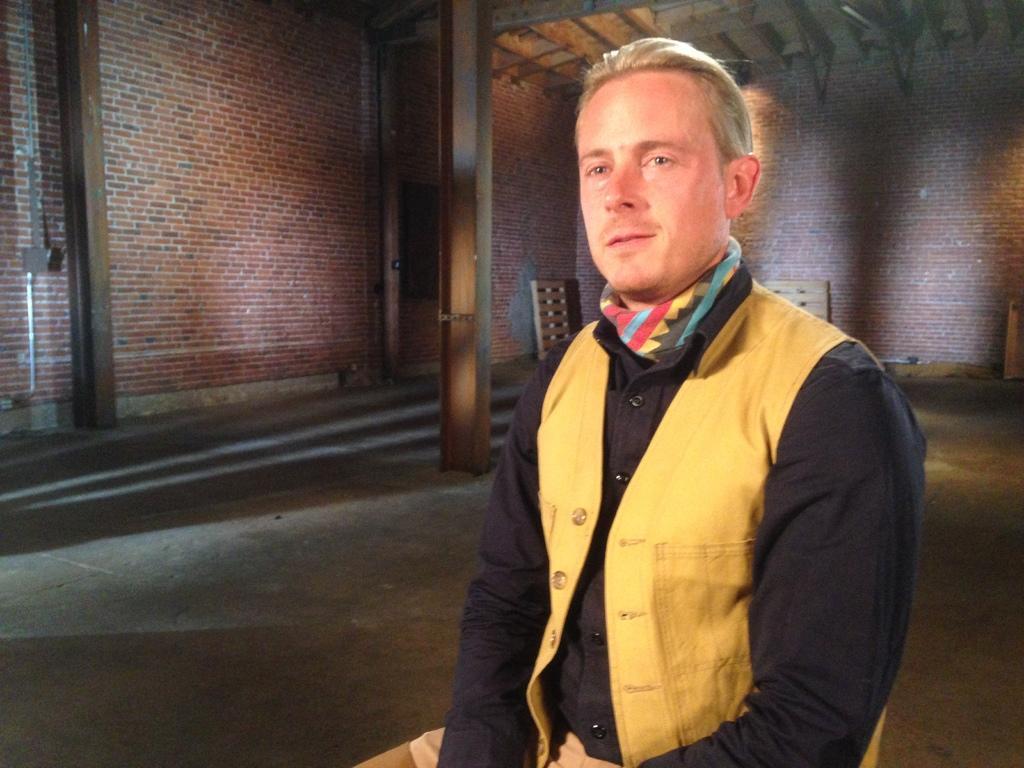Could you give a brief overview of what you see in this image? In this picture we can see a man is sitting in the front, in the background there is a brick wall, we can see a pillar in the middle. 